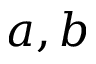Convert formula to latex. <formula><loc_0><loc_0><loc_500><loc_500>a , b</formula> 